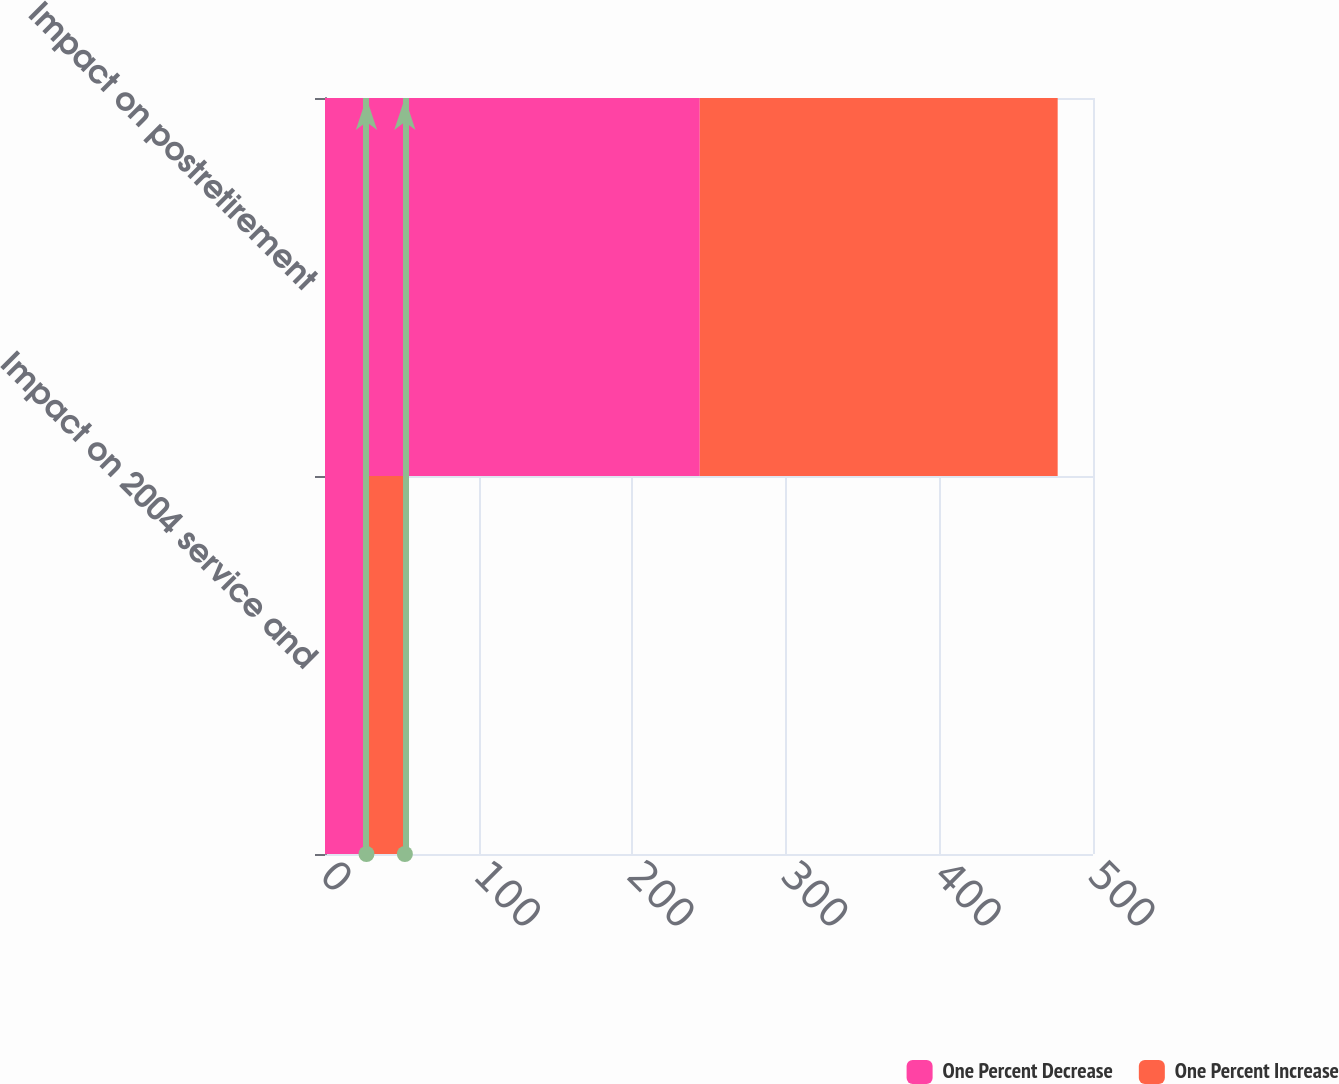<chart> <loc_0><loc_0><loc_500><loc_500><stacked_bar_chart><ecel><fcel>Impact on 2004 service and<fcel>Impact on postretirement<nl><fcel>One Percent Decrease<fcel>27<fcel>244<nl><fcel>One Percent Increase<fcel>25<fcel>233<nl></chart> 